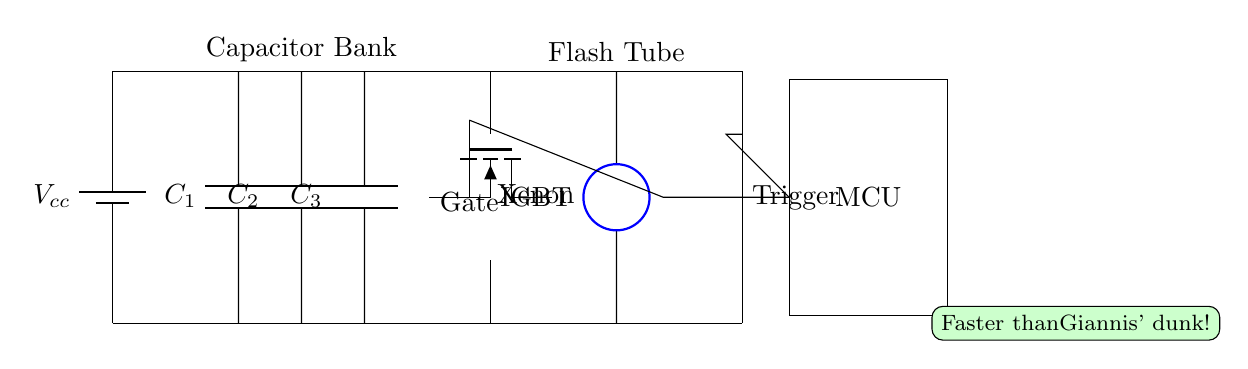What is the main power source in this circuit? The main power source is indicated by the battery symbol at the left side, where it shows the voltage as Vcc.
Answer: Vcc What type of switch is used in the circuit? The switch is indicated by the IGBT symbol, which is specifically a type of power electronic switch designed for high-speed operations.
Answer: IGBT How many capacitors are present in the circuit? The diagram shows three capacitors labeled C1, C2, and C3 connected in parallel, each having their own connection.
Answer: Three What component triggers the flash in this circuit? The component that triggers the flash is identified as the 'Trigger Transformer' symbol, which is necessary for igniting the xenon flash tube.
Answer: Trigger Transformer What is the purpose of the microcontroller in this circuit? The microcontroller (MCU) is responsible for controlling the gate of the IGBT, coordinating the timing for the flash activation based on inputs or programming.
Answer: Control How does the flash get powered when activated? The capacitors C1, C2, and C3 charge from the power supply and discharge through the IGBT switch into the xenon flash tube when activated, creating the flash.
Answer: Charge discharge What is the significance of the annotation "Faster than Giannis' dunk!"? The annotation humorously compares the speed of the flash system to the speed of basketball player Giannis, illustrating that the flash is designed for quick action, suitable for capturing fast sports moments.
Answer: Humor 